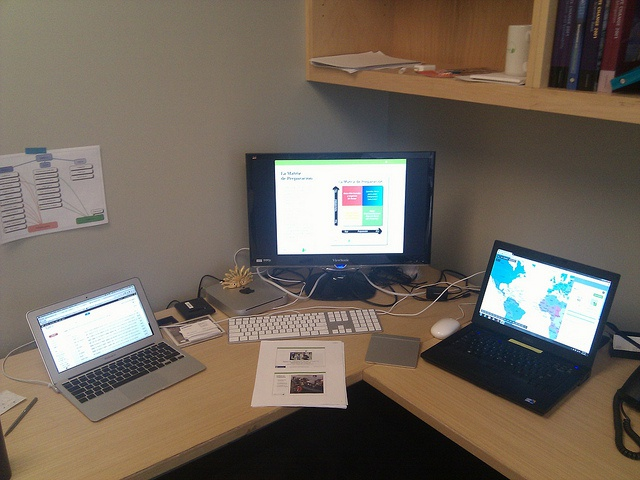Describe the objects in this image and their specific colors. I can see tv in gray, white, navy, black, and darkblue tones, laptop in gray, black, white, navy, and lightblue tones, laptop in gray, white, and black tones, book in gray, black, and maroon tones, and keyboard in gray, black, navy, and olive tones in this image. 